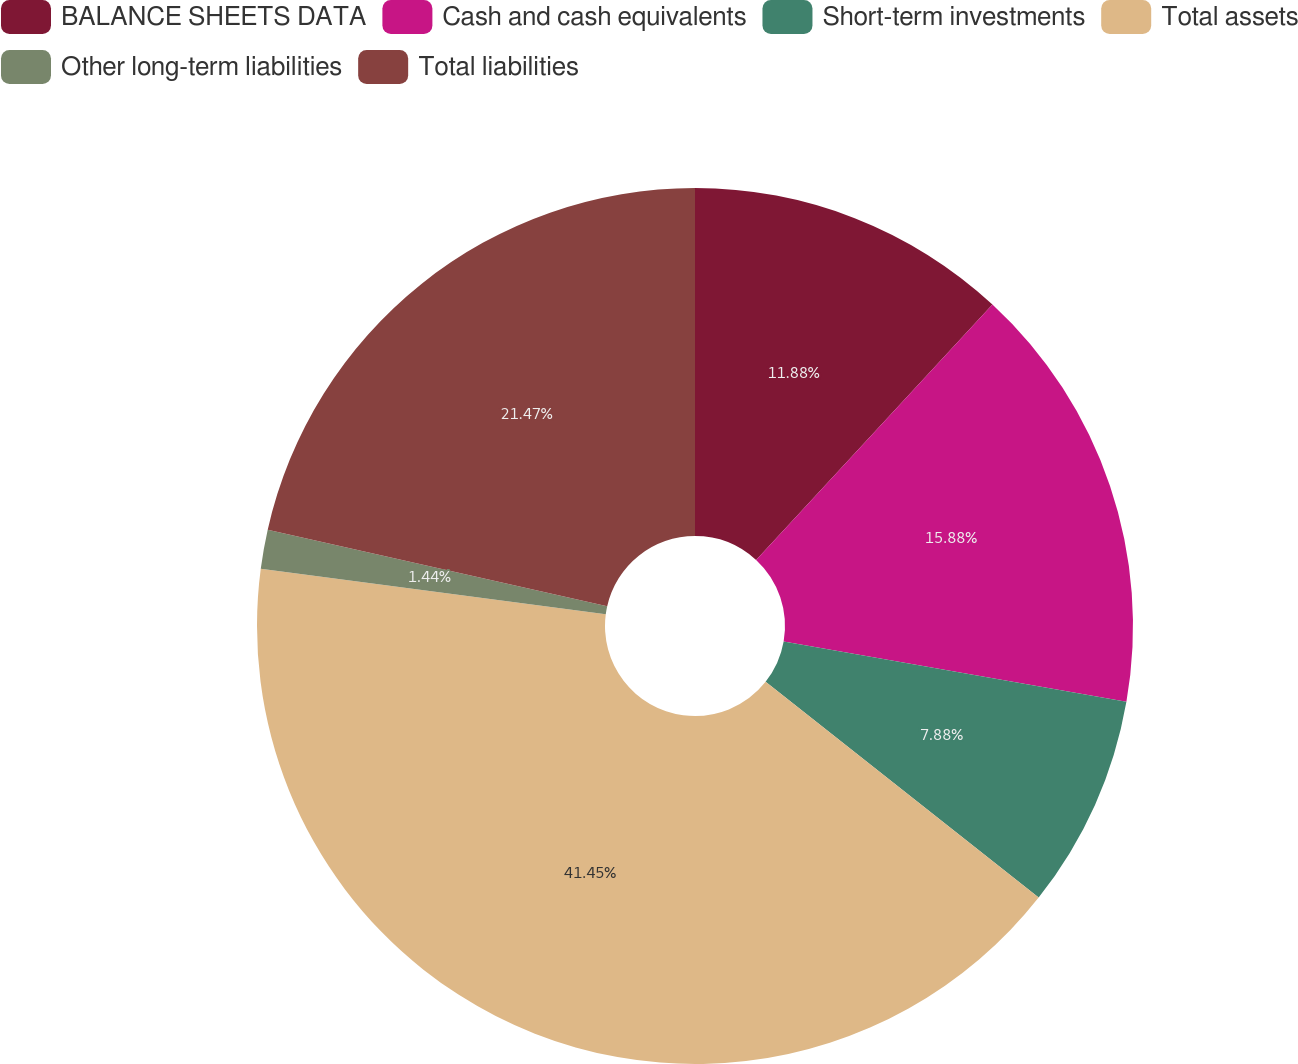Convert chart. <chart><loc_0><loc_0><loc_500><loc_500><pie_chart><fcel>BALANCE SHEETS DATA<fcel>Cash and cash equivalents<fcel>Short-term investments<fcel>Total assets<fcel>Other long-term liabilities<fcel>Total liabilities<nl><fcel>11.88%<fcel>15.88%<fcel>7.88%<fcel>41.44%<fcel>1.44%<fcel>21.47%<nl></chart> 